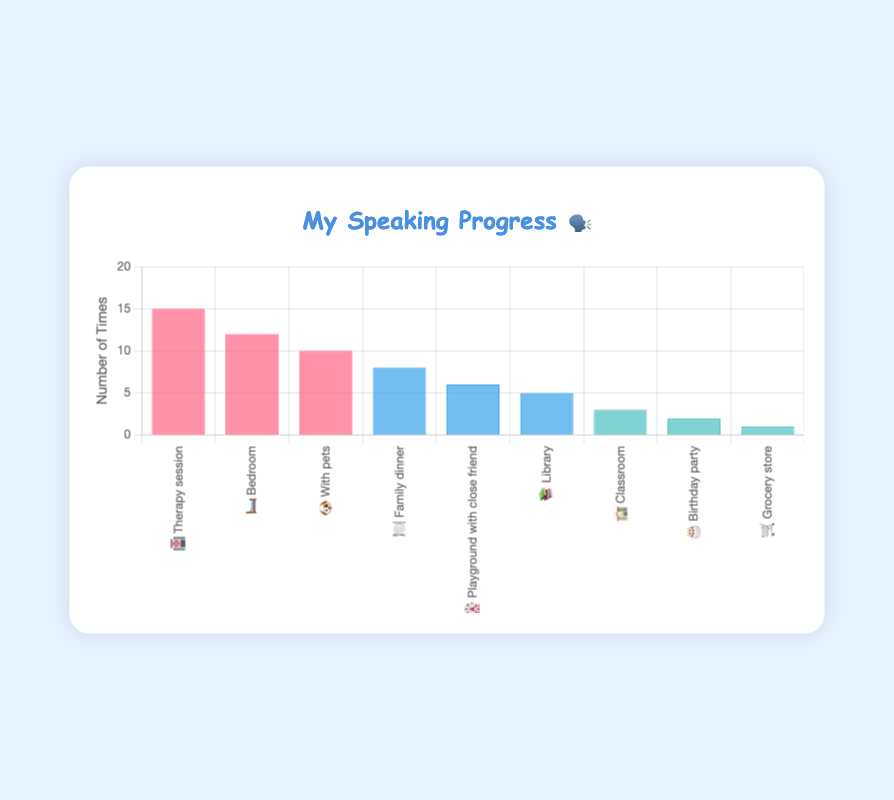What are the three locations where I felt the highest comfort while speaking? The three locations with the highest number of occurrences are "Therapy session 🏥", "Bedroom 🛏️", and "With pets 🐶". Just refer to the highest occurrences under "High Comfort".
Answer: Therapy session 🏥, Bedroom 🛏️, With pets 🐶 Which three locations had the fewest speaking occurrences? The three locations with the lowest occurrences are "Grocery store 🛒", "Birthday party 🎂", and "Classroom 🏫". They have the fewest bars in the "Low Comfort" category.
Answer: Grocery store 🛒, Birthday party 🎂, Classroom 🏫 How many total times did I speak in medium comfort situations? Summing the occurrences in medium comfort situations: (8 from Family dinner 🍽️) + (6 from Playground 🎡) + (5 from Library 📚) = 19 times
Answer: 19 times What is the difference in speaking occurrences between 'Therapy session 🏥' and 'Grocery store 🛒'? The difference is calculated as: occurrences in Therapy session 🏥 (15) - occurrences in Grocery store 🛒 (1) = 14 times
Answer: 14 times What's the average number of speaking occurrences in low comfort situations? First, sum the occurrences in low comfort: (3 from Classroom 🏫) + (2 from Birthday party 🎂) + (1 from Grocery store 🛒) = 6. Then, divide by the number of situations (3): 6 / 3 = 2.
Answer: 2 Which situation had the highest number of speaking occurrences? The situation with the highest number of occurrences is "Therapy session 🏥" with 15 occurrences. Check for the tallest bar.
Answer: Therapy session 🏥 How many more times did I speak in the bedroom 🛏️ compared to the playground 🎡? Comparing "Bedroom 🛏️" (12 occurrences) and "Playground 🎡" (6 occurrences): 12 - 6 = 6 times more significant.
Answer: 6 times more Is there any location where speaking occurred exactly five times? The "Library 📚" had 5 speaking occurrences. Refer to the value on the bar corresponding to the Library (📚).
Answer: Library 📚 